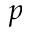<formula> <loc_0><loc_0><loc_500><loc_500>p</formula> 